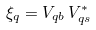Convert formula to latex. <formula><loc_0><loc_0><loc_500><loc_500>\xi _ { q } = V _ { q b } \, V ^ { * } _ { q s }</formula> 